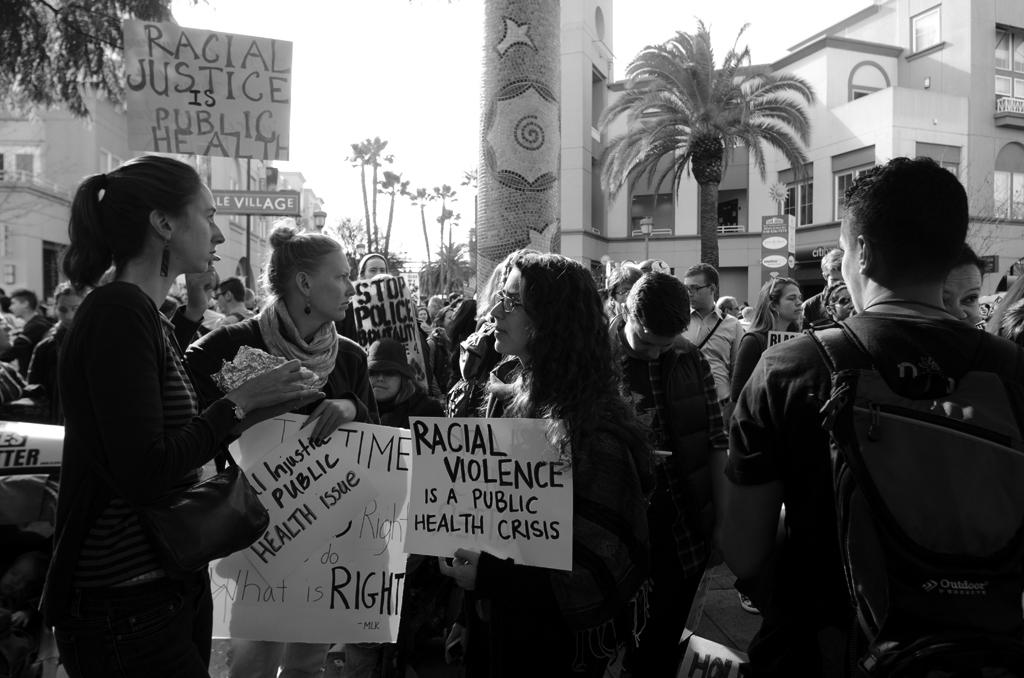What is happening in the center of the image? There are people in the center of the image. What are the people holding in the image? The people are holding posters. What can be seen in the background of the image? There are buildings and trees in the background of the image. How much sugar is in the doctor's coffee in the image? There is no doctor or coffee present in the image, so it is not possible to determine the amount of sugar in the coffee. 